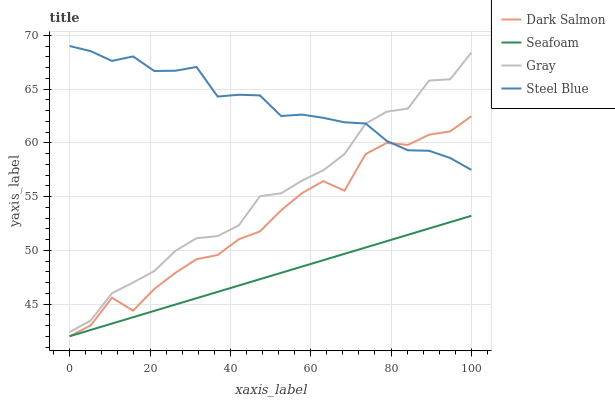Does Seafoam have the minimum area under the curve?
Answer yes or no. Yes. Does Steel Blue have the maximum area under the curve?
Answer yes or no. Yes. Does Dark Salmon have the minimum area under the curve?
Answer yes or no. No. Does Dark Salmon have the maximum area under the curve?
Answer yes or no. No. Is Seafoam the smoothest?
Answer yes or no. Yes. Is Dark Salmon the roughest?
Answer yes or no. Yes. Is Steel Blue the smoothest?
Answer yes or no. No. Is Steel Blue the roughest?
Answer yes or no. No. Does Dark Salmon have the lowest value?
Answer yes or no. Yes. Does Steel Blue have the lowest value?
Answer yes or no. No. Does Steel Blue have the highest value?
Answer yes or no. Yes. Does Dark Salmon have the highest value?
Answer yes or no. No. Is Seafoam less than Steel Blue?
Answer yes or no. Yes. Is Gray greater than Dark Salmon?
Answer yes or no. Yes. Does Gray intersect Steel Blue?
Answer yes or no. Yes. Is Gray less than Steel Blue?
Answer yes or no. No. Is Gray greater than Steel Blue?
Answer yes or no. No. Does Seafoam intersect Steel Blue?
Answer yes or no. No. 